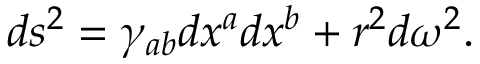Convert formula to latex. <formula><loc_0><loc_0><loc_500><loc_500>d s ^ { 2 } = \gamma _ { a b } d x ^ { a } d x ^ { b } + r ^ { 2 } d \omega ^ { 2 } .</formula> 